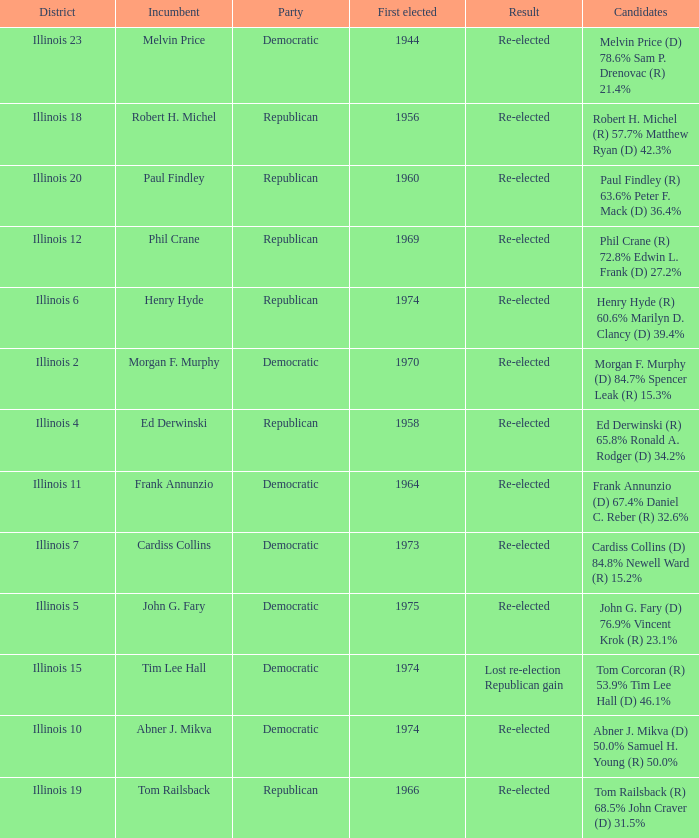Name the first elected for abner j. mikva 1974.0. 